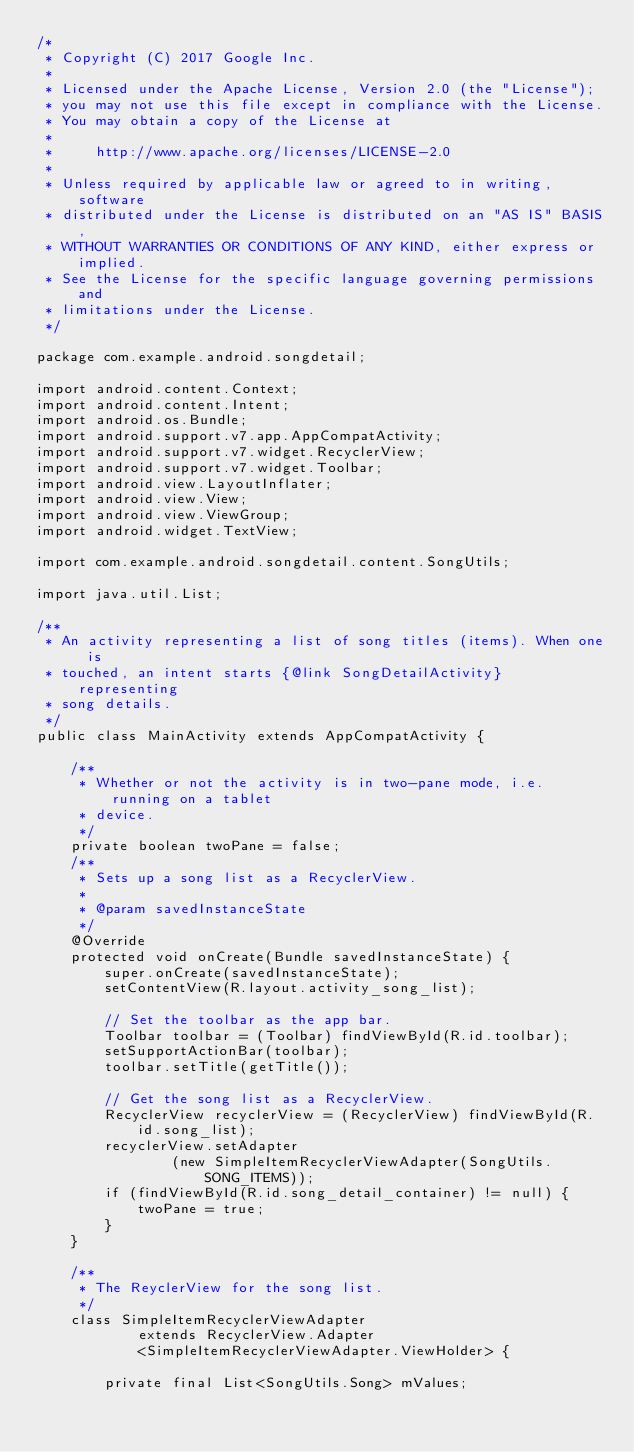Convert code to text. <code><loc_0><loc_0><loc_500><loc_500><_Java_>/*
 * Copyright (C) 2017 Google Inc.
 *
 * Licensed under the Apache License, Version 2.0 (the "License");
 * you may not use this file except in compliance with the License.
 * You may obtain a copy of the License at
 *
 *     http://www.apache.org/licenses/LICENSE-2.0
 *
 * Unless required by applicable law or agreed to in writing, software
 * distributed under the License is distributed on an "AS IS" BASIS,
 * WITHOUT WARRANTIES OR CONDITIONS OF ANY KIND, either express or implied.
 * See the License for the specific language governing permissions and
 * limitations under the License.
 */

package com.example.android.songdetail;

import android.content.Context;
import android.content.Intent;
import android.os.Bundle;
import android.support.v7.app.AppCompatActivity;
import android.support.v7.widget.RecyclerView;
import android.support.v7.widget.Toolbar;
import android.view.LayoutInflater;
import android.view.View;
import android.view.ViewGroup;
import android.widget.TextView;

import com.example.android.songdetail.content.SongUtils;

import java.util.List;

/**
 * An activity representing a list of song titles (items). When one is
 * touched, an intent starts {@link SongDetailActivity} representing
 * song details.
 */
public class MainActivity extends AppCompatActivity {

    /**
     * Whether or not the activity is in two-pane mode, i.e. running on a tablet
     * device.
     */
    private boolean twoPane = false;
    /**
     * Sets up a song list as a RecyclerView.
     *
     * @param savedInstanceState
     */
    @Override
    protected void onCreate(Bundle savedInstanceState) {
        super.onCreate(savedInstanceState);
        setContentView(R.layout.activity_song_list);

        // Set the toolbar as the app bar.
        Toolbar toolbar = (Toolbar) findViewById(R.id.toolbar);
        setSupportActionBar(toolbar);
        toolbar.setTitle(getTitle());

        // Get the song list as a RecyclerView.
        RecyclerView recyclerView = (RecyclerView) findViewById(R.id.song_list);
        recyclerView.setAdapter
                (new SimpleItemRecyclerViewAdapter(SongUtils.SONG_ITEMS));
        if (findViewById(R.id.song_detail_container) != null) {
            twoPane = true;
        }
    }

    /**
     * The ReyclerView for the song list.
     */
    class SimpleItemRecyclerViewAdapter
            extends RecyclerView.Adapter
            <SimpleItemRecyclerViewAdapter.ViewHolder> {

        private final List<SongUtils.Song> mValues;
</code> 